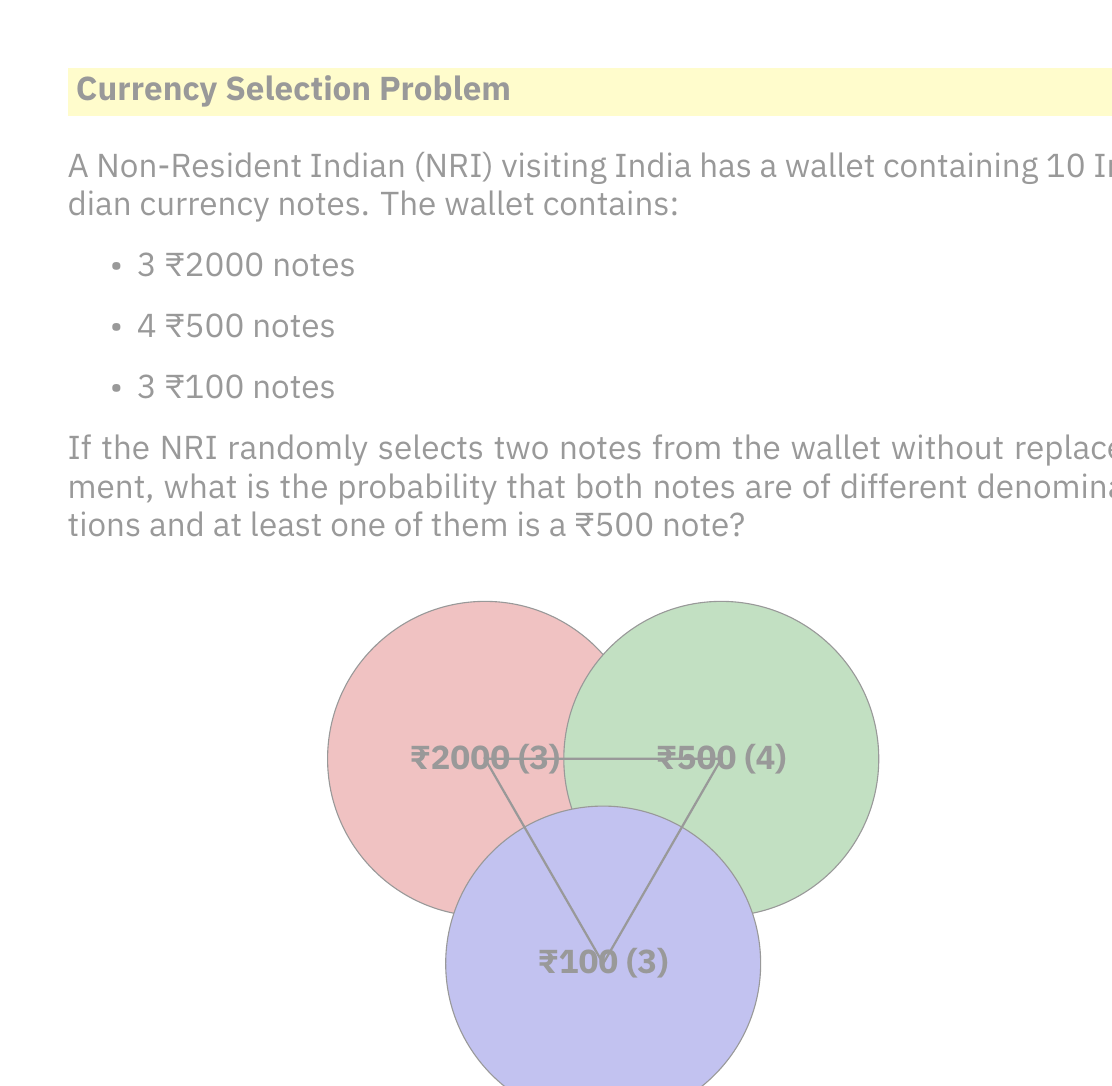Provide a solution to this math problem. Let's approach this step-by-step:

1) First, we need to calculate the total number of ways to select 2 notes out of 10:
   $$\binom{10}{2} = \frac{10!}{2!(10-2)!} = 45$$

2) Now, we need to find the number of favorable outcomes. There are three cases:
   a) ₹2000 and ₹500
   b) ₹2000 and ₹100
   c) ₹500 and ₹100

3) Let's calculate each:
   a) ₹2000 and ₹500: $3 \times 4 = 12$ ways
   b) ₹2000 and ₹100: $3 \times 3 = 9$ ways
   c) ₹500 and ₹100: $4 \times 3 = 12$ ways

4) However, the question asks for at least one ₹500 note, so we only need to sum cases a) and c):
   $12 + 12 = 24$ favorable outcomes

5) The probability is therefore:
   $$P(\text{different denominations with at least one ₹500}) = \frac{24}{45} = \frac{8}{15}$$

6) This can be simplified to:
   $$\frac{8}{15} \approx 0.5333$$

Thus, the probability is $\frac{8}{15}$ or approximately 53.33%.
Answer: $\frac{8}{15}$ 